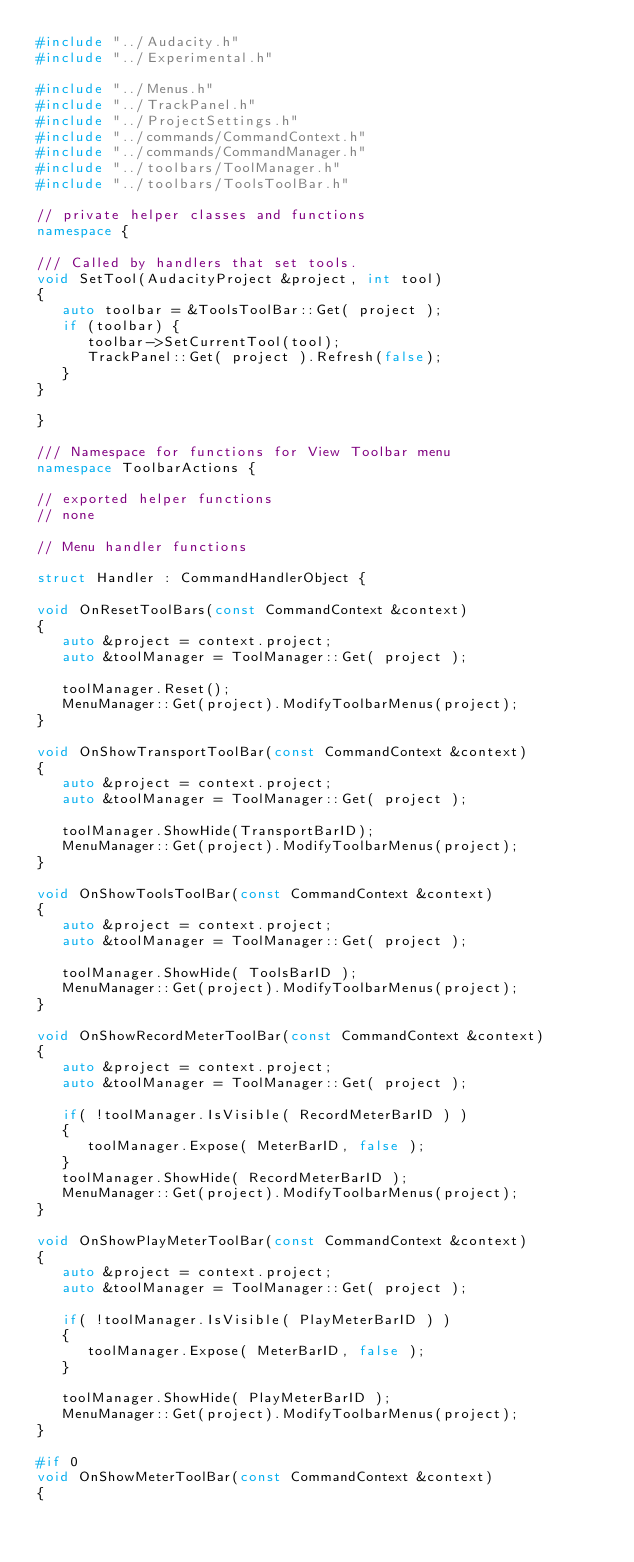<code> <loc_0><loc_0><loc_500><loc_500><_C++_>#include "../Audacity.h"
#include "../Experimental.h"

#include "../Menus.h"
#include "../TrackPanel.h"
#include "../ProjectSettings.h"
#include "../commands/CommandContext.h"
#include "../commands/CommandManager.h"
#include "../toolbars/ToolManager.h"
#include "../toolbars/ToolsToolBar.h"

// private helper classes and functions
namespace {

/// Called by handlers that set tools.
void SetTool(AudacityProject &project, int tool)
{
   auto toolbar = &ToolsToolBar::Get( project );
   if (toolbar) {
      toolbar->SetCurrentTool(tool);
      TrackPanel::Get( project ).Refresh(false);
   }
}

}

/// Namespace for functions for View Toolbar menu
namespace ToolbarActions {

// exported helper functions
// none

// Menu handler functions

struct Handler : CommandHandlerObject {

void OnResetToolBars(const CommandContext &context)
{
   auto &project = context.project;
   auto &toolManager = ToolManager::Get( project );

   toolManager.Reset();
   MenuManager::Get(project).ModifyToolbarMenus(project);
}

void OnShowTransportToolBar(const CommandContext &context)
{
   auto &project = context.project;
   auto &toolManager = ToolManager::Get( project );

   toolManager.ShowHide(TransportBarID);
   MenuManager::Get(project).ModifyToolbarMenus(project);
}

void OnShowToolsToolBar(const CommandContext &context)
{
   auto &project = context.project;
   auto &toolManager = ToolManager::Get( project );

   toolManager.ShowHide( ToolsBarID );
   MenuManager::Get(project).ModifyToolbarMenus(project);
}

void OnShowRecordMeterToolBar(const CommandContext &context)
{
   auto &project = context.project;
   auto &toolManager = ToolManager::Get( project );

   if( !toolManager.IsVisible( RecordMeterBarID ) )
   {
      toolManager.Expose( MeterBarID, false );
   }
   toolManager.ShowHide( RecordMeterBarID );
   MenuManager::Get(project).ModifyToolbarMenus(project);
}

void OnShowPlayMeterToolBar(const CommandContext &context)
{
   auto &project = context.project;
   auto &toolManager = ToolManager::Get( project );

   if( !toolManager.IsVisible( PlayMeterBarID ) )
   {
      toolManager.Expose( MeterBarID, false );
   }

   toolManager.ShowHide( PlayMeterBarID );
   MenuManager::Get(project).ModifyToolbarMenus(project);
}

#if 0
void OnShowMeterToolBar(const CommandContext &context)
{</code> 